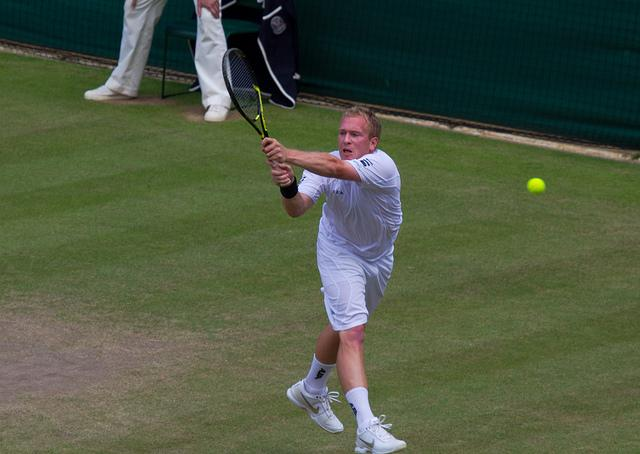What is the player ready to do?

Choices:
A) sprint
B) bat
C) swing
D) dribble swing 